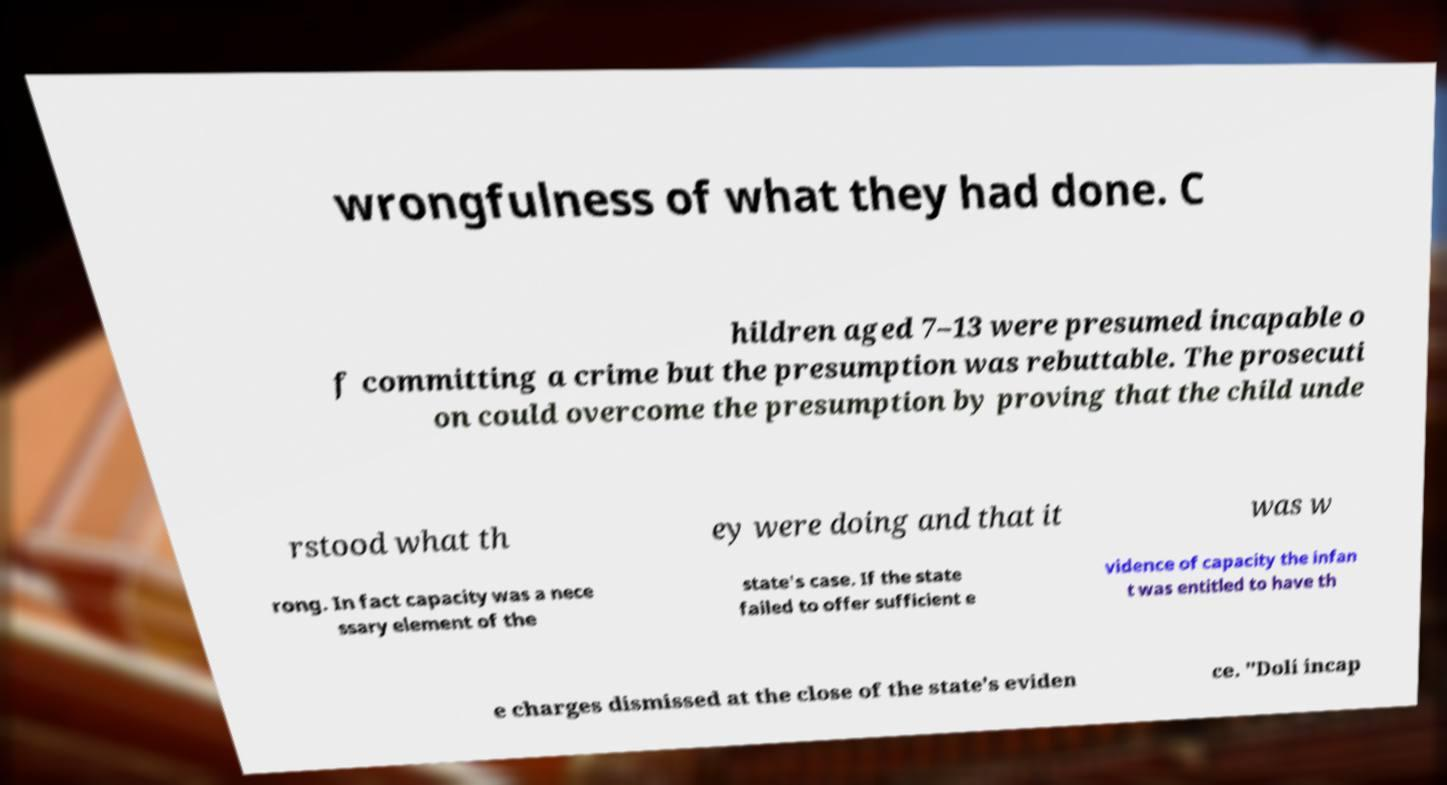I need the written content from this picture converted into text. Can you do that? wrongfulness of what they had done. C hildren aged 7–13 were presumed incapable o f committing a crime but the presumption was rebuttable. The prosecuti on could overcome the presumption by proving that the child unde rstood what th ey were doing and that it was w rong. In fact capacity was a nece ssary element of the state's case. If the state failed to offer sufficient e vidence of capacity the infan t was entitled to have th e charges dismissed at the close of the state's eviden ce. "Doli incap 